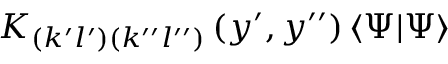<formula> <loc_0><loc_0><loc_500><loc_500>K _ { \left ( k ^ { \prime } l ^ { \prime } \right ) \left ( k ^ { \prime \prime } l ^ { \prime \prime } \right ) } \left ( y ^ { \prime } , y ^ { \prime \prime } \right ) \left \langle \Psi | \Psi \right \rangle</formula> 